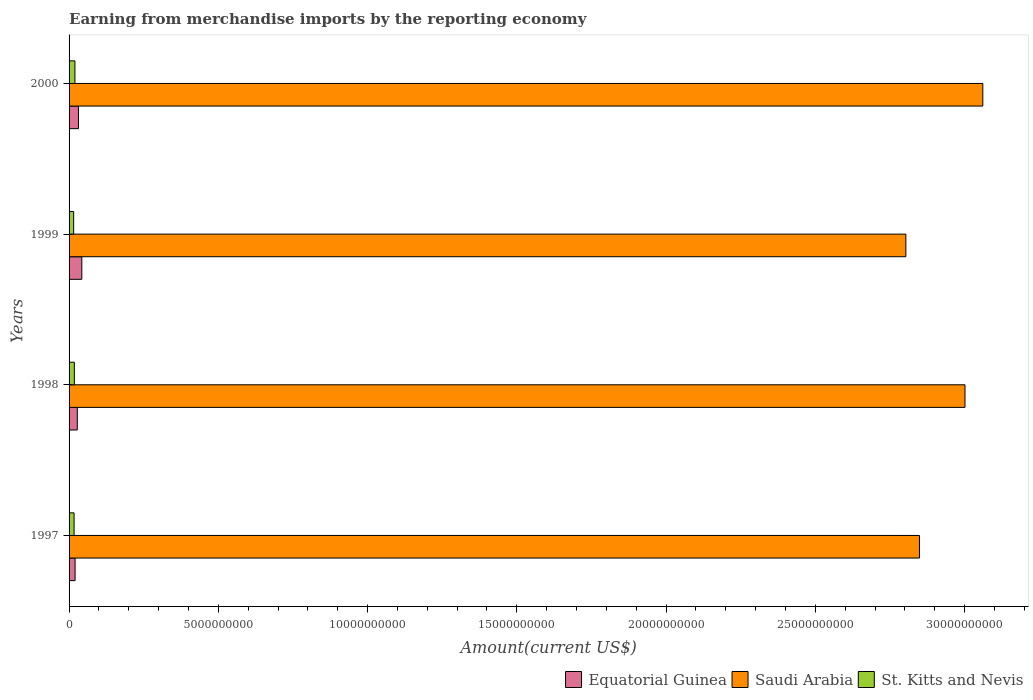How many different coloured bars are there?
Keep it short and to the point. 3. Are the number of bars per tick equal to the number of legend labels?
Provide a succinct answer. Yes. Are the number of bars on each tick of the Y-axis equal?
Offer a very short reply. Yes. How many bars are there on the 3rd tick from the bottom?
Ensure brevity in your answer.  3. In how many cases, is the number of bars for a given year not equal to the number of legend labels?
Keep it short and to the point. 0. What is the amount earned from merchandise imports in Equatorial Guinea in 1999?
Provide a succinct answer. 4.27e+08. Across all years, what is the maximum amount earned from merchandise imports in St. Kitts and Nevis?
Make the answer very short. 1.96e+08. Across all years, what is the minimum amount earned from merchandise imports in Saudi Arabia?
Your answer should be very brief. 2.80e+1. In which year was the amount earned from merchandise imports in Saudi Arabia maximum?
Offer a very short reply. 2000. In which year was the amount earned from merchandise imports in St. Kitts and Nevis minimum?
Keep it short and to the point. 1999. What is the total amount earned from merchandise imports in Saudi Arabia in the graph?
Ensure brevity in your answer.  1.17e+11. What is the difference between the amount earned from merchandise imports in Equatorial Guinea in 1997 and that in 1998?
Provide a short and direct response. -7.38e+07. What is the difference between the amount earned from merchandise imports in Saudi Arabia in 2000 and the amount earned from merchandise imports in St. Kitts and Nevis in 1999?
Offer a very short reply. 3.05e+1. What is the average amount earned from merchandise imports in Equatorial Guinea per year?
Offer a terse response. 3.04e+08. In the year 1997, what is the difference between the amount earned from merchandise imports in Equatorial Guinea and amount earned from merchandise imports in Saudi Arabia?
Offer a very short reply. -2.83e+1. What is the ratio of the amount earned from merchandise imports in Equatorial Guinea in 1999 to that in 2000?
Your answer should be very brief. 1.36. What is the difference between the highest and the second highest amount earned from merchandise imports in Saudi Arabia?
Provide a succinct answer. 5.97e+08. What is the difference between the highest and the lowest amount earned from merchandise imports in Equatorial Guinea?
Provide a short and direct response. 2.25e+08. Is the sum of the amount earned from merchandise imports in St. Kitts and Nevis in 1998 and 2000 greater than the maximum amount earned from merchandise imports in Saudi Arabia across all years?
Provide a succinct answer. No. What does the 1st bar from the top in 2000 represents?
Your response must be concise. St. Kitts and Nevis. What does the 2nd bar from the bottom in 1998 represents?
Provide a short and direct response. Saudi Arabia. How many years are there in the graph?
Your answer should be very brief. 4. Are the values on the major ticks of X-axis written in scientific E-notation?
Keep it short and to the point. No. Does the graph contain any zero values?
Provide a short and direct response. No. Where does the legend appear in the graph?
Your answer should be compact. Bottom right. What is the title of the graph?
Your response must be concise. Earning from merchandise imports by the reporting economy. Does "Dominican Republic" appear as one of the legend labels in the graph?
Offer a very short reply. No. What is the label or title of the X-axis?
Your response must be concise. Amount(current US$). What is the Amount(current US$) of Equatorial Guinea in 1997?
Ensure brevity in your answer.  2.01e+08. What is the Amount(current US$) of Saudi Arabia in 1997?
Make the answer very short. 2.85e+1. What is the Amount(current US$) of St. Kitts and Nevis in 1997?
Give a very brief answer. 1.68e+08. What is the Amount(current US$) of Equatorial Guinea in 1998?
Keep it short and to the point. 2.75e+08. What is the Amount(current US$) in Saudi Arabia in 1998?
Provide a succinct answer. 3.00e+1. What is the Amount(current US$) of St. Kitts and Nevis in 1998?
Provide a succinct answer. 1.77e+08. What is the Amount(current US$) of Equatorial Guinea in 1999?
Provide a succinct answer. 4.27e+08. What is the Amount(current US$) of Saudi Arabia in 1999?
Provide a succinct answer. 2.80e+1. What is the Amount(current US$) in St. Kitts and Nevis in 1999?
Your answer should be very brief. 1.54e+08. What is the Amount(current US$) in Equatorial Guinea in 2000?
Offer a terse response. 3.15e+08. What is the Amount(current US$) in Saudi Arabia in 2000?
Offer a very short reply. 3.06e+1. What is the Amount(current US$) in St. Kitts and Nevis in 2000?
Provide a short and direct response. 1.96e+08. Across all years, what is the maximum Amount(current US$) in Equatorial Guinea?
Provide a succinct answer. 4.27e+08. Across all years, what is the maximum Amount(current US$) in Saudi Arabia?
Your answer should be compact. 3.06e+1. Across all years, what is the maximum Amount(current US$) of St. Kitts and Nevis?
Offer a very short reply. 1.96e+08. Across all years, what is the minimum Amount(current US$) in Equatorial Guinea?
Provide a short and direct response. 2.01e+08. Across all years, what is the minimum Amount(current US$) in Saudi Arabia?
Offer a terse response. 2.80e+1. Across all years, what is the minimum Amount(current US$) of St. Kitts and Nevis?
Ensure brevity in your answer.  1.54e+08. What is the total Amount(current US$) of Equatorial Guinea in the graph?
Make the answer very short. 1.22e+09. What is the total Amount(current US$) in Saudi Arabia in the graph?
Make the answer very short. 1.17e+11. What is the total Amount(current US$) in St. Kitts and Nevis in the graph?
Offer a very short reply. 6.94e+08. What is the difference between the Amount(current US$) in Equatorial Guinea in 1997 and that in 1998?
Ensure brevity in your answer.  -7.38e+07. What is the difference between the Amount(current US$) of Saudi Arabia in 1997 and that in 1998?
Ensure brevity in your answer.  -1.52e+09. What is the difference between the Amount(current US$) in St. Kitts and Nevis in 1997 and that in 1998?
Ensure brevity in your answer.  -9.20e+06. What is the difference between the Amount(current US$) in Equatorial Guinea in 1997 and that in 1999?
Offer a very short reply. -2.25e+08. What is the difference between the Amount(current US$) in Saudi Arabia in 1997 and that in 1999?
Provide a succinct answer. 4.56e+08. What is the difference between the Amount(current US$) in St. Kitts and Nevis in 1997 and that in 1999?
Make the answer very short. 1.41e+07. What is the difference between the Amount(current US$) of Equatorial Guinea in 1997 and that in 2000?
Ensure brevity in your answer.  -1.13e+08. What is the difference between the Amount(current US$) of Saudi Arabia in 1997 and that in 2000?
Your answer should be very brief. -2.12e+09. What is the difference between the Amount(current US$) of St. Kitts and Nevis in 1997 and that in 2000?
Make the answer very short. -2.83e+07. What is the difference between the Amount(current US$) of Equatorial Guinea in 1998 and that in 1999?
Keep it short and to the point. -1.51e+08. What is the difference between the Amount(current US$) of Saudi Arabia in 1998 and that in 1999?
Give a very brief answer. 1.98e+09. What is the difference between the Amount(current US$) in St. Kitts and Nevis in 1998 and that in 1999?
Your response must be concise. 2.33e+07. What is the difference between the Amount(current US$) of Equatorial Guinea in 1998 and that in 2000?
Ensure brevity in your answer.  -3.94e+07. What is the difference between the Amount(current US$) of Saudi Arabia in 1998 and that in 2000?
Provide a short and direct response. -5.97e+08. What is the difference between the Amount(current US$) of St. Kitts and Nevis in 1998 and that in 2000?
Keep it short and to the point. -1.91e+07. What is the difference between the Amount(current US$) of Equatorial Guinea in 1999 and that in 2000?
Keep it short and to the point. 1.12e+08. What is the difference between the Amount(current US$) of Saudi Arabia in 1999 and that in 2000?
Provide a succinct answer. -2.58e+09. What is the difference between the Amount(current US$) in St. Kitts and Nevis in 1999 and that in 2000?
Your answer should be compact. -4.24e+07. What is the difference between the Amount(current US$) of Equatorial Guinea in 1997 and the Amount(current US$) of Saudi Arabia in 1998?
Your answer should be compact. -2.98e+1. What is the difference between the Amount(current US$) in Equatorial Guinea in 1997 and the Amount(current US$) in St. Kitts and Nevis in 1998?
Make the answer very short. 2.45e+07. What is the difference between the Amount(current US$) in Saudi Arabia in 1997 and the Amount(current US$) in St. Kitts and Nevis in 1998?
Ensure brevity in your answer.  2.83e+1. What is the difference between the Amount(current US$) in Equatorial Guinea in 1997 and the Amount(current US$) in Saudi Arabia in 1999?
Offer a very short reply. -2.78e+1. What is the difference between the Amount(current US$) in Equatorial Guinea in 1997 and the Amount(current US$) in St. Kitts and Nevis in 1999?
Ensure brevity in your answer.  4.79e+07. What is the difference between the Amount(current US$) of Saudi Arabia in 1997 and the Amount(current US$) of St. Kitts and Nevis in 1999?
Give a very brief answer. 2.83e+1. What is the difference between the Amount(current US$) of Equatorial Guinea in 1997 and the Amount(current US$) of Saudi Arabia in 2000?
Give a very brief answer. -3.04e+1. What is the difference between the Amount(current US$) of Equatorial Guinea in 1997 and the Amount(current US$) of St. Kitts and Nevis in 2000?
Ensure brevity in your answer.  5.44e+06. What is the difference between the Amount(current US$) in Saudi Arabia in 1997 and the Amount(current US$) in St. Kitts and Nevis in 2000?
Keep it short and to the point. 2.83e+1. What is the difference between the Amount(current US$) in Equatorial Guinea in 1998 and the Amount(current US$) in Saudi Arabia in 1999?
Keep it short and to the point. -2.78e+1. What is the difference between the Amount(current US$) of Equatorial Guinea in 1998 and the Amount(current US$) of St. Kitts and Nevis in 1999?
Your answer should be very brief. 1.22e+08. What is the difference between the Amount(current US$) in Saudi Arabia in 1998 and the Amount(current US$) in St. Kitts and Nevis in 1999?
Make the answer very short. 2.99e+1. What is the difference between the Amount(current US$) in Equatorial Guinea in 1998 and the Amount(current US$) in Saudi Arabia in 2000?
Your response must be concise. -3.03e+1. What is the difference between the Amount(current US$) in Equatorial Guinea in 1998 and the Amount(current US$) in St. Kitts and Nevis in 2000?
Provide a short and direct response. 7.93e+07. What is the difference between the Amount(current US$) in Saudi Arabia in 1998 and the Amount(current US$) in St. Kitts and Nevis in 2000?
Keep it short and to the point. 2.98e+1. What is the difference between the Amount(current US$) in Equatorial Guinea in 1999 and the Amount(current US$) in Saudi Arabia in 2000?
Keep it short and to the point. -3.02e+1. What is the difference between the Amount(current US$) in Equatorial Guinea in 1999 and the Amount(current US$) in St. Kitts and Nevis in 2000?
Give a very brief answer. 2.31e+08. What is the difference between the Amount(current US$) of Saudi Arabia in 1999 and the Amount(current US$) of St. Kitts and Nevis in 2000?
Your answer should be very brief. 2.78e+1. What is the average Amount(current US$) of Equatorial Guinea per year?
Your answer should be very brief. 3.04e+08. What is the average Amount(current US$) of Saudi Arabia per year?
Ensure brevity in your answer.  2.93e+1. What is the average Amount(current US$) in St. Kitts and Nevis per year?
Offer a terse response. 1.74e+08. In the year 1997, what is the difference between the Amount(current US$) of Equatorial Guinea and Amount(current US$) of Saudi Arabia?
Give a very brief answer. -2.83e+1. In the year 1997, what is the difference between the Amount(current US$) of Equatorial Guinea and Amount(current US$) of St. Kitts and Nevis?
Provide a succinct answer. 3.37e+07. In the year 1997, what is the difference between the Amount(current US$) in Saudi Arabia and Amount(current US$) in St. Kitts and Nevis?
Offer a terse response. 2.83e+1. In the year 1998, what is the difference between the Amount(current US$) of Equatorial Guinea and Amount(current US$) of Saudi Arabia?
Offer a terse response. -2.97e+1. In the year 1998, what is the difference between the Amount(current US$) of Equatorial Guinea and Amount(current US$) of St. Kitts and Nevis?
Your answer should be compact. 9.84e+07. In the year 1998, what is the difference between the Amount(current US$) of Saudi Arabia and Amount(current US$) of St. Kitts and Nevis?
Your answer should be compact. 2.98e+1. In the year 1999, what is the difference between the Amount(current US$) in Equatorial Guinea and Amount(current US$) in Saudi Arabia?
Offer a very short reply. -2.76e+1. In the year 1999, what is the difference between the Amount(current US$) in Equatorial Guinea and Amount(current US$) in St. Kitts and Nevis?
Offer a very short reply. 2.73e+08. In the year 1999, what is the difference between the Amount(current US$) in Saudi Arabia and Amount(current US$) in St. Kitts and Nevis?
Provide a succinct answer. 2.79e+1. In the year 2000, what is the difference between the Amount(current US$) in Equatorial Guinea and Amount(current US$) in Saudi Arabia?
Offer a very short reply. -3.03e+1. In the year 2000, what is the difference between the Amount(current US$) of Equatorial Guinea and Amount(current US$) of St. Kitts and Nevis?
Your response must be concise. 1.19e+08. In the year 2000, what is the difference between the Amount(current US$) of Saudi Arabia and Amount(current US$) of St. Kitts and Nevis?
Offer a very short reply. 3.04e+1. What is the ratio of the Amount(current US$) in Equatorial Guinea in 1997 to that in 1998?
Your answer should be compact. 0.73. What is the ratio of the Amount(current US$) in Saudi Arabia in 1997 to that in 1998?
Provide a short and direct response. 0.95. What is the ratio of the Amount(current US$) in St. Kitts and Nevis in 1997 to that in 1998?
Keep it short and to the point. 0.95. What is the ratio of the Amount(current US$) in Equatorial Guinea in 1997 to that in 1999?
Offer a very short reply. 0.47. What is the ratio of the Amount(current US$) in Saudi Arabia in 1997 to that in 1999?
Offer a very short reply. 1.02. What is the ratio of the Amount(current US$) in St. Kitts and Nevis in 1997 to that in 1999?
Your answer should be compact. 1.09. What is the ratio of the Amount(current US$) in Equatorial Guinea in 1997 to that in 2000?
Make the answer very short. 0.64. What is the ratio of the Amount(current US$) in Saudi Arabia in 1997 to that in 2000?
Offer a terse response. 0.93. What is the ratio of the Amount(current US$) in St. Kitts and Nevis in 1997 to that in 2000?
Provide a succinct answer. 0.86. What is the ratio of the Amount(current US$) of Equatorial Guinea in 1998 to that in 1999?
Your response must be concise. 0.65. What is the ratio of the Amount(current US$) in Saudi Arabia in 1998 to that in 1999?
Your response must be concise. 1.07. What is the ratio of the Amount(current US$) in St. Kitts and Nevis in 1998 to that in 1999?
Make the answer very short. 1.15. What is the ratio of the Amount(current US$) in Equatorial Guinea in 1998 to that in 2000?
Provide a short and direct response. 0.87. What is the ratio of the Amount(current US$) of Saudi Arabia in 1998 to that in 2000?
Provide a succinct answer. 0.98. What is the ratio of the Amount(current US$) in St. Kitts and Nevis in 1998 to that in 2000?
Ensure brevity in your answer.  0.9. What is the ratio of the Amount(current US$) of Equatorial Guinea in 1999 to that in 2000?
Your response must be concise. 1.36. What is the ratio of the Amount(current US$) of Saudi Arabia in 1999 to that in 2000?
Your response must be concise. 0.92. What is the ratio of the Amount(current US$) in St. Kitts and Nevis in 1999 to that in 2000?
Your answer should be compact. 0.78. What is the difference between the highest and the second highest Amount(current US$) of Equatorial Guinea?
Your answer should be compact. 1.12e+08. What is the difference between the highest and the second highest Amount(current US$) of Saudi Arabia?
Provide a short and direct response. 5.97e+08. What is the difference between the highest and the second highest Amount(current US$) of St. Kitts and Nevis?
Your answer should be very brief. 1.91e+07. What is the difference between the highest and the lowest Amount(current US$) in Equatorial Guinea?
Offer a terse response. 2.25e+08. What is the difference between the highest and the lowest Amount(current US$) of Saudi Arabia?
Your response must be concise. 2.58e+09. What is the difference between the highest and the lowest Amount(current US$) in St. Kitts and Nevis?
Your answer should be very brief. 4.24e+07. 